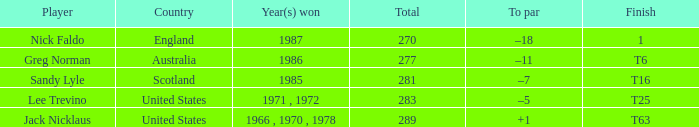How many totals have t6 as the finish? 277.0. 